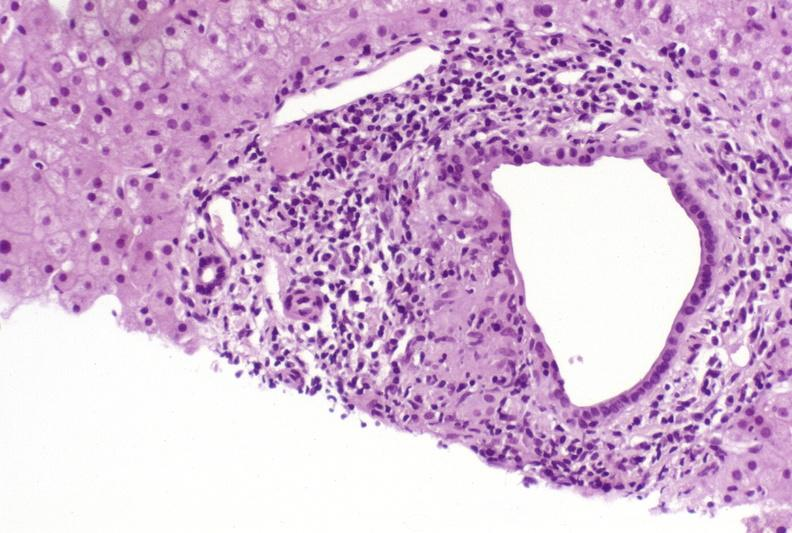does this image show primary biliary cirrhosis?
Answer the question using a single word or phrase. Yes 